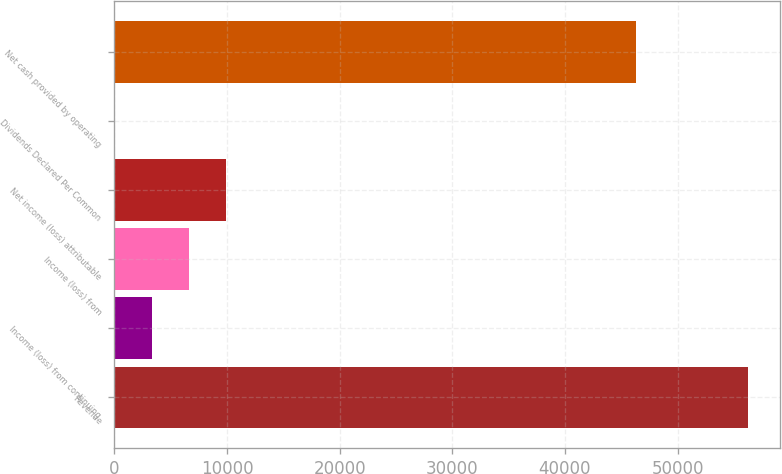<chart> <loc_0><loc_0><loc_500><loc_500><bar_chart><fcel>Revenue<fcel>Income (loss) from continuing<fcel>Income (loss) from<fcel>Net income (loss) attributable<fcel>Dividends Declared Per Common<fcel>Net cash provided by operating<nl><fcel>56290<fcel>3311.64<fcel>6622.79<fcel>9933.94<fcel>0.49<fcel>46356.6<nl></chart> 